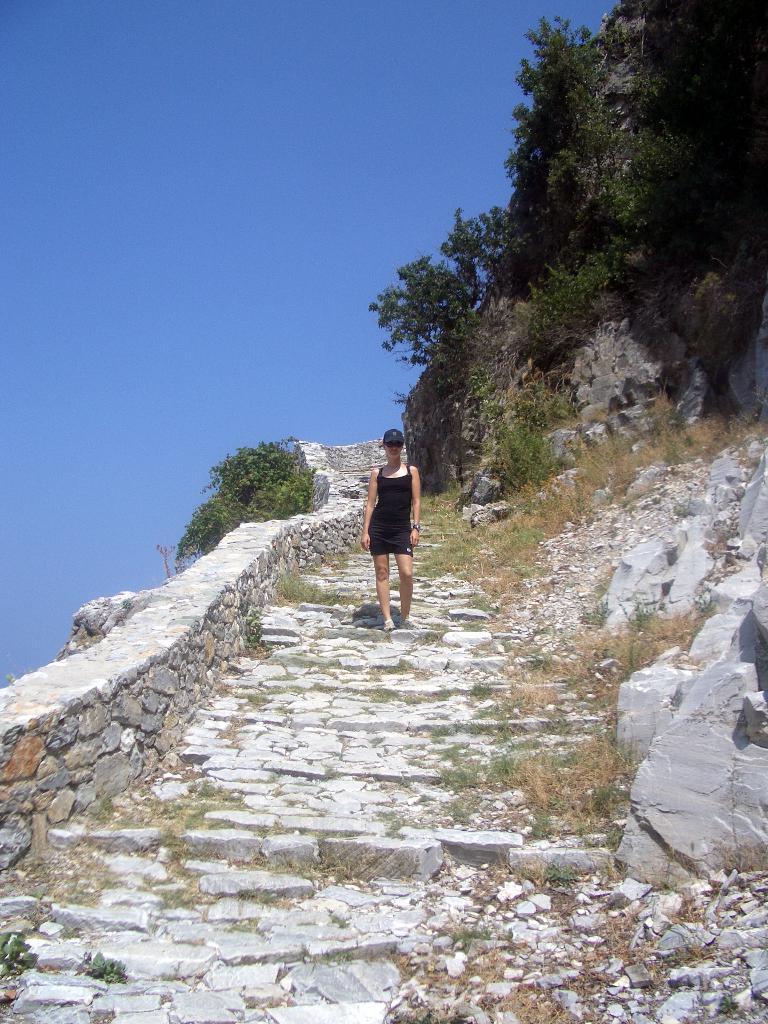Describe this image in one or two sentences. In the image there is a woman in black dress walking on the steps with trees on either side of it and a fence on the left side and above its sky. 